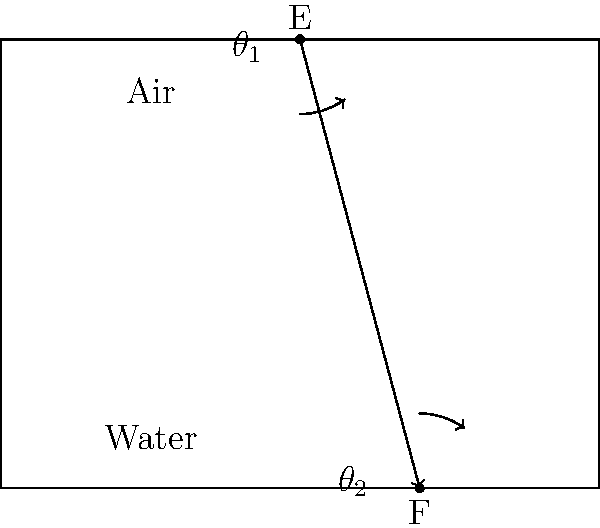A ray of light passes from air into water, as shown in the diagram. If the angle of incidence ($\theta_1$) is 37° and the refractive index of water is 1.33, calculate the angle of refraction ($\theta_2$) to the nearest degree. To solve this problem, we'll use Snell's Law, which relates the angles of incidence and refraction to the refractive indices of the media:

1) Snell's Law: $n_1 \sin(\theta_1) = n_2 \sin(\theta_2)$

2) We know:
   - $n_1 = 1.00$ (refractive index of air)
   - $n_2 = 1.33$ (refractive index of water)
   - $\theta_1 = 37°$ (angle of incidence)

3) Substituting into Snell's Law:
   $1.00 \sin(37°) = 1.33 \sin(\theta_2)$

4) Simplify:
   $\sin(37°) = 1.33 \sin(\theta_2)$

5) Solve for $\sin(\theta_2)$:
   $\sin(\theta_2) = \frac{\sin(37°)}{1.33}$

6) Calculate:
   $\sin(\theta_2) = \frac{0.6018}{1.33} = 0.4525$

7) Take the inverse sine (arcsin) of both sides:
   $\theta_2 = \arcsin(0.4525) = 26.9°$

8) Rounding to the nearest degree:
   $\theta_2 \approx 27°$
Answer: 27° 